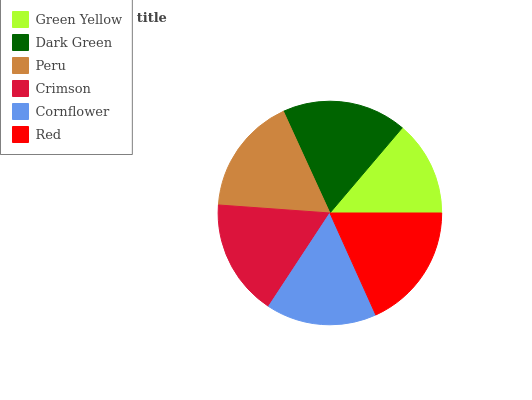Is Green Yellow the minimum?
Answer yes or no. Yes. Is Red the maximum?
Answer yes or no. Yes. Is Dark Green the minimum?
Answer yes or no. No. Is Dark Green the maximum?
Answer yes or no. No. Is Dark Green greater than Green Yellow?
Answer yes or no. Yes. Is Green Yellow less than Dark Green?
Answer yes or no. Yes. Is Green Yellow greater than Dark Green?
Answer yes or no. No. Is Dark Green less than Green Yellow?
Answer yes or no. No. Is Peru the high median?
Answer yes or no. Yes. Is Crimson the low median?
Answer yes or no. Yes. Is Dark Green the high median?
Answer yes or no. No. Is Cornflower the low median?
Answer yes or no. No. 